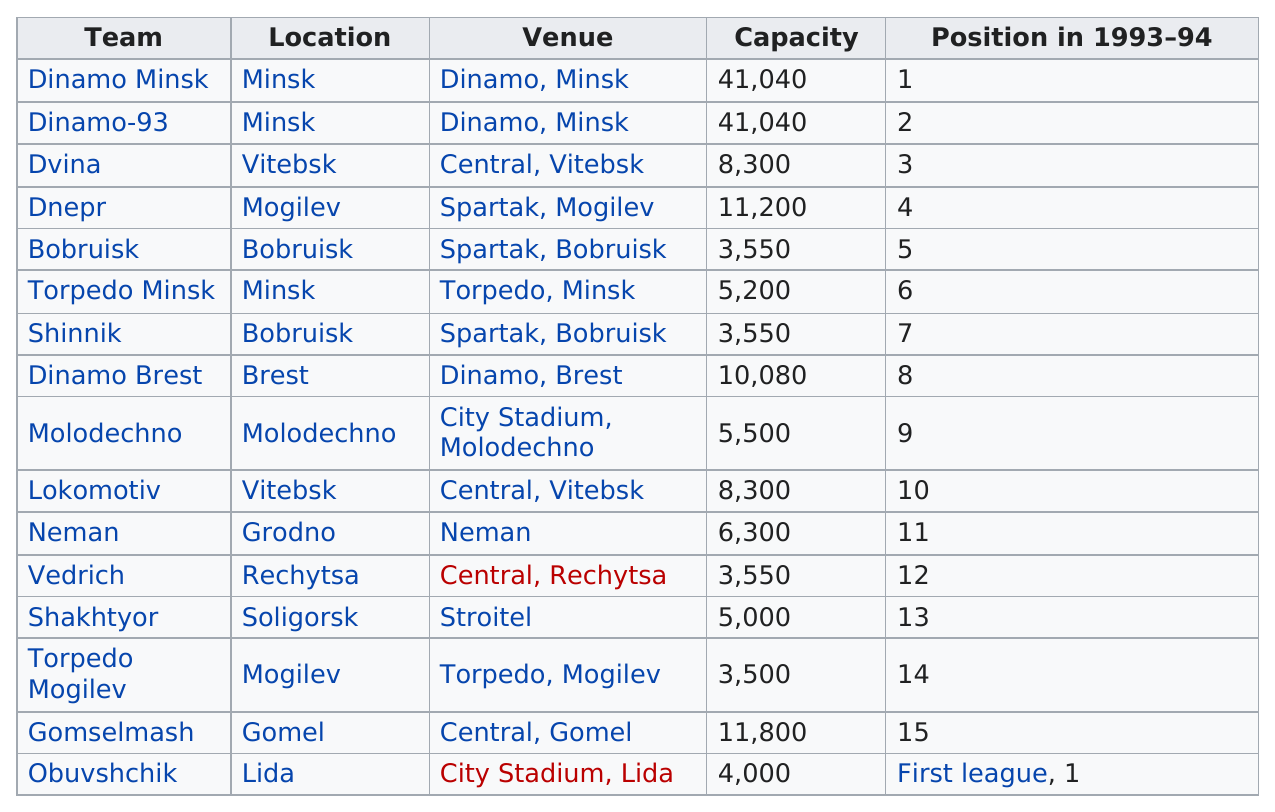Give some essential details in this illustration. The first venue on this chart had a capacity of 41,040 people. There are a total of three teams located in Minsk. The Dinamo Minsk team held the first position during the 1993-94 season. There were a total of three occasions where Minsk was listed as a location. The name of the last team listed on this chart is Obuvshchik. 